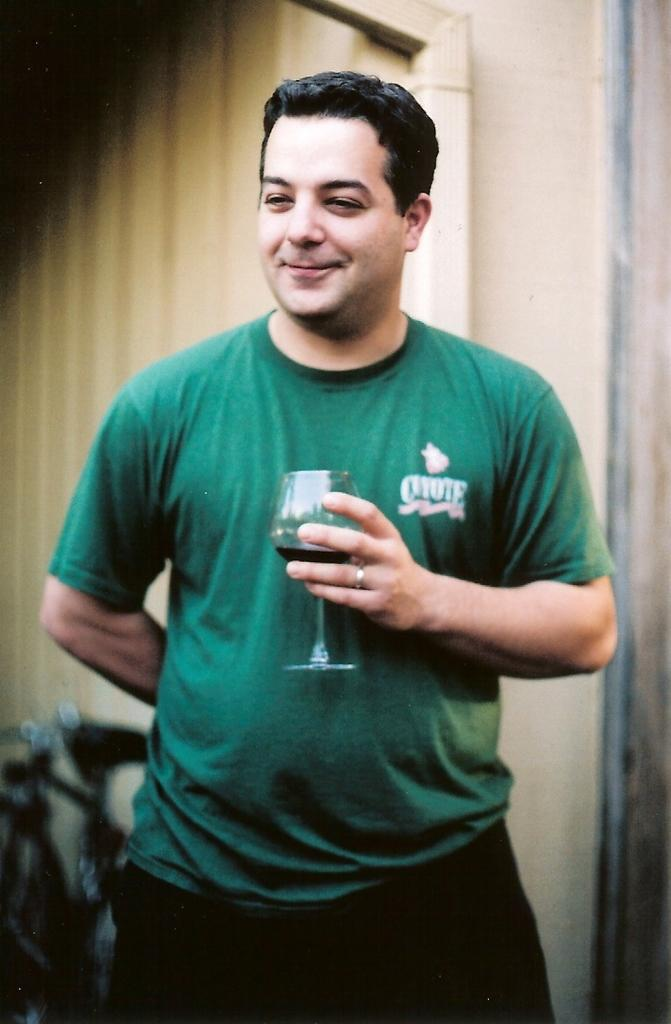What is the man in the image doing with his hand? The man is holding a glass in his hand. What is the man's facial expression in the image? The man is smiling. What can be seen in the background of the image? There is a wall, a pipe, and a bicycle in the background of the image. What is the weight of the glass the man is holding in the image? The weight of the glass cannot be determined from the image alone, as it depends on the size and material of the glass. 